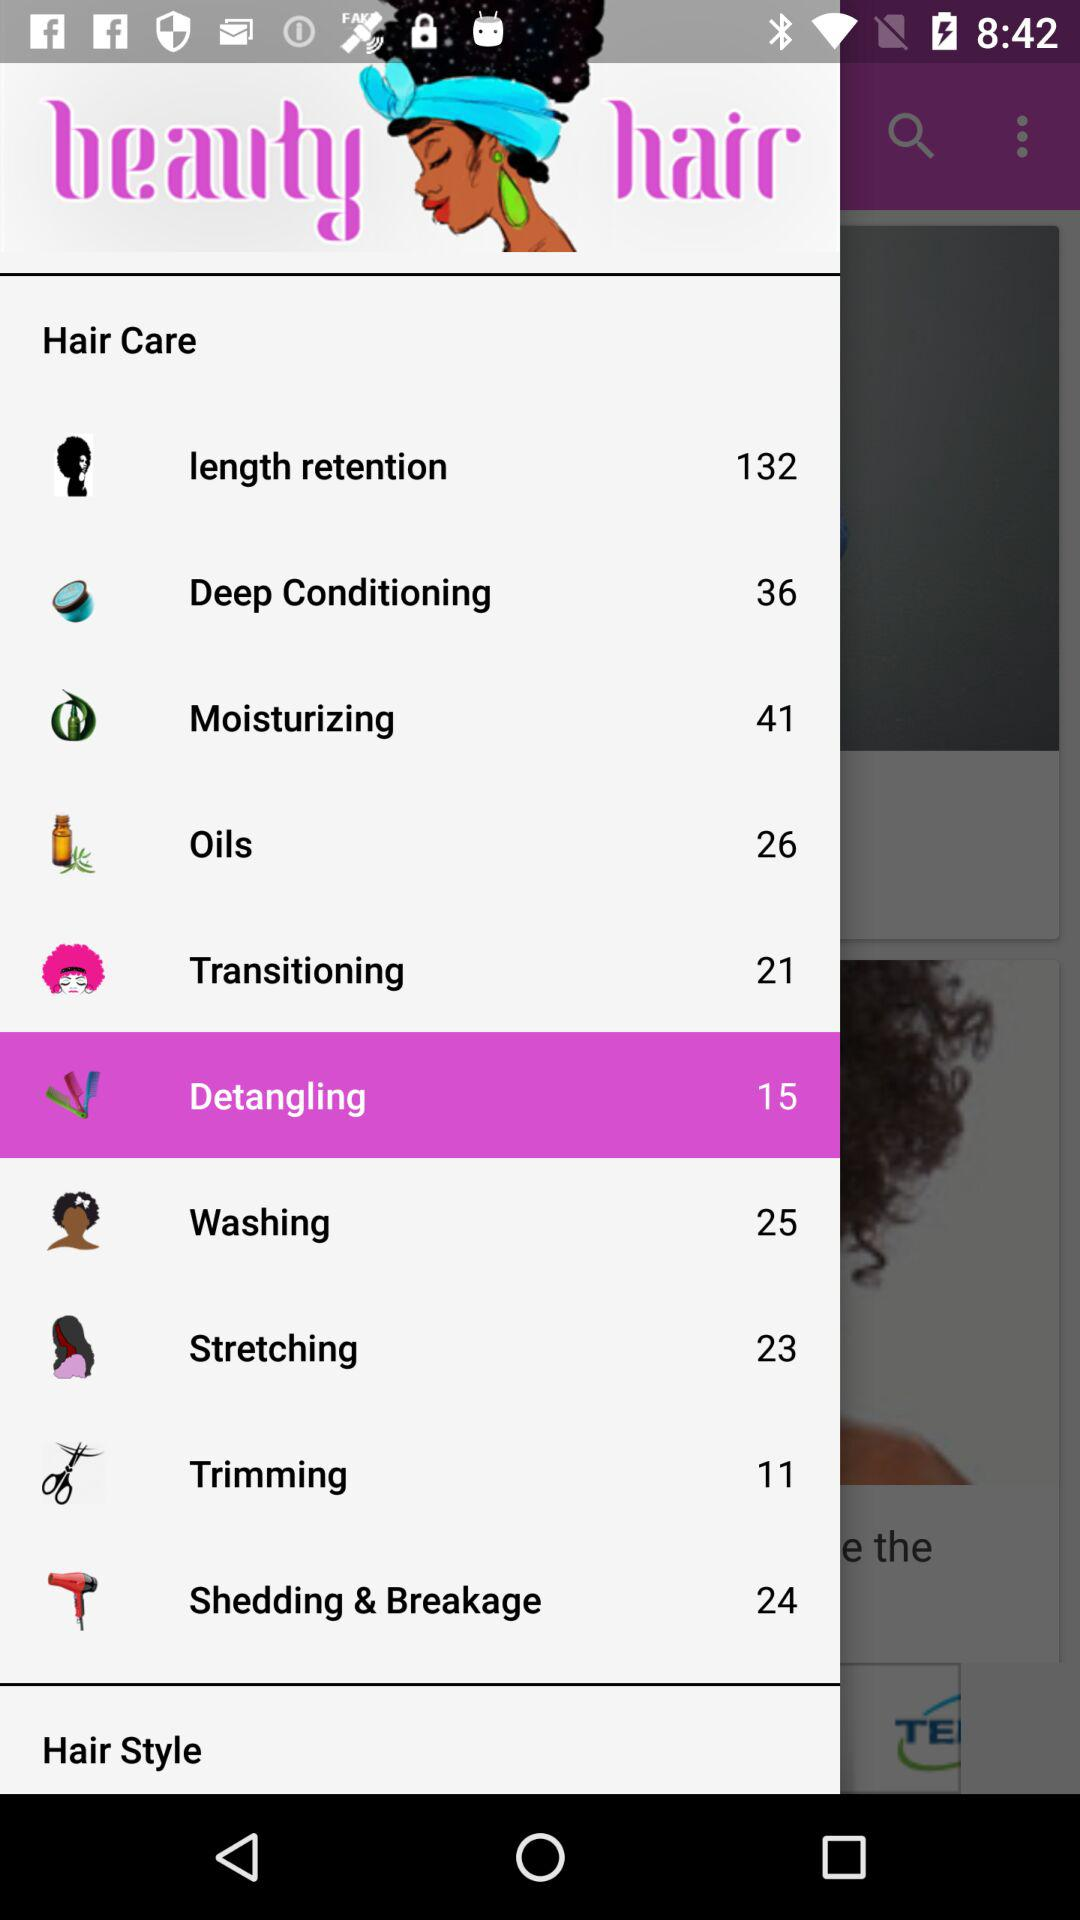How many hair care topics are there?
Answer the question using a single word or phrase. 10 